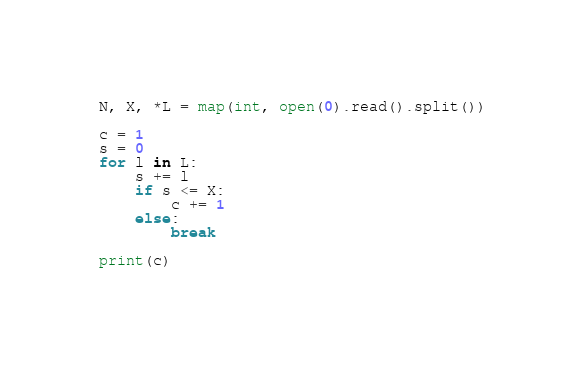<code> <loc_0><loc_0><loc_500><loc_500><_Python_>N, X, *L = map(int, open(0).read().split())

c = 1
s = 0
for l in L:
    s += l 
    if s <= X:
        c += 1
    else:
        break

print(c)</code> 